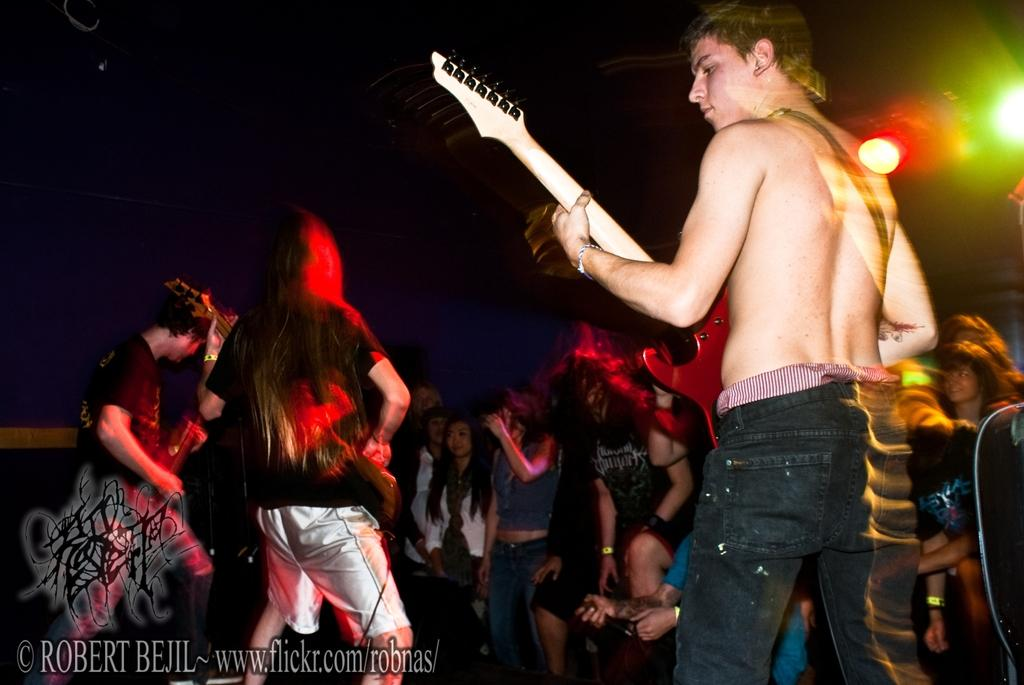What are the three people in the image doing? The three people in the image are playing guitar. Are there any other people visible in the image? Yes, there are people standing in front of the guitar players. Is there any text or symbol in the image? Yes, there is a watermark in the left bottom of the image. Can you see any horns being played by the people at the seashore in the image? There is no seashore or horns present in the image; it features three people playing guitar. Is there any glue visible in the image? There is no glue present in the image. 